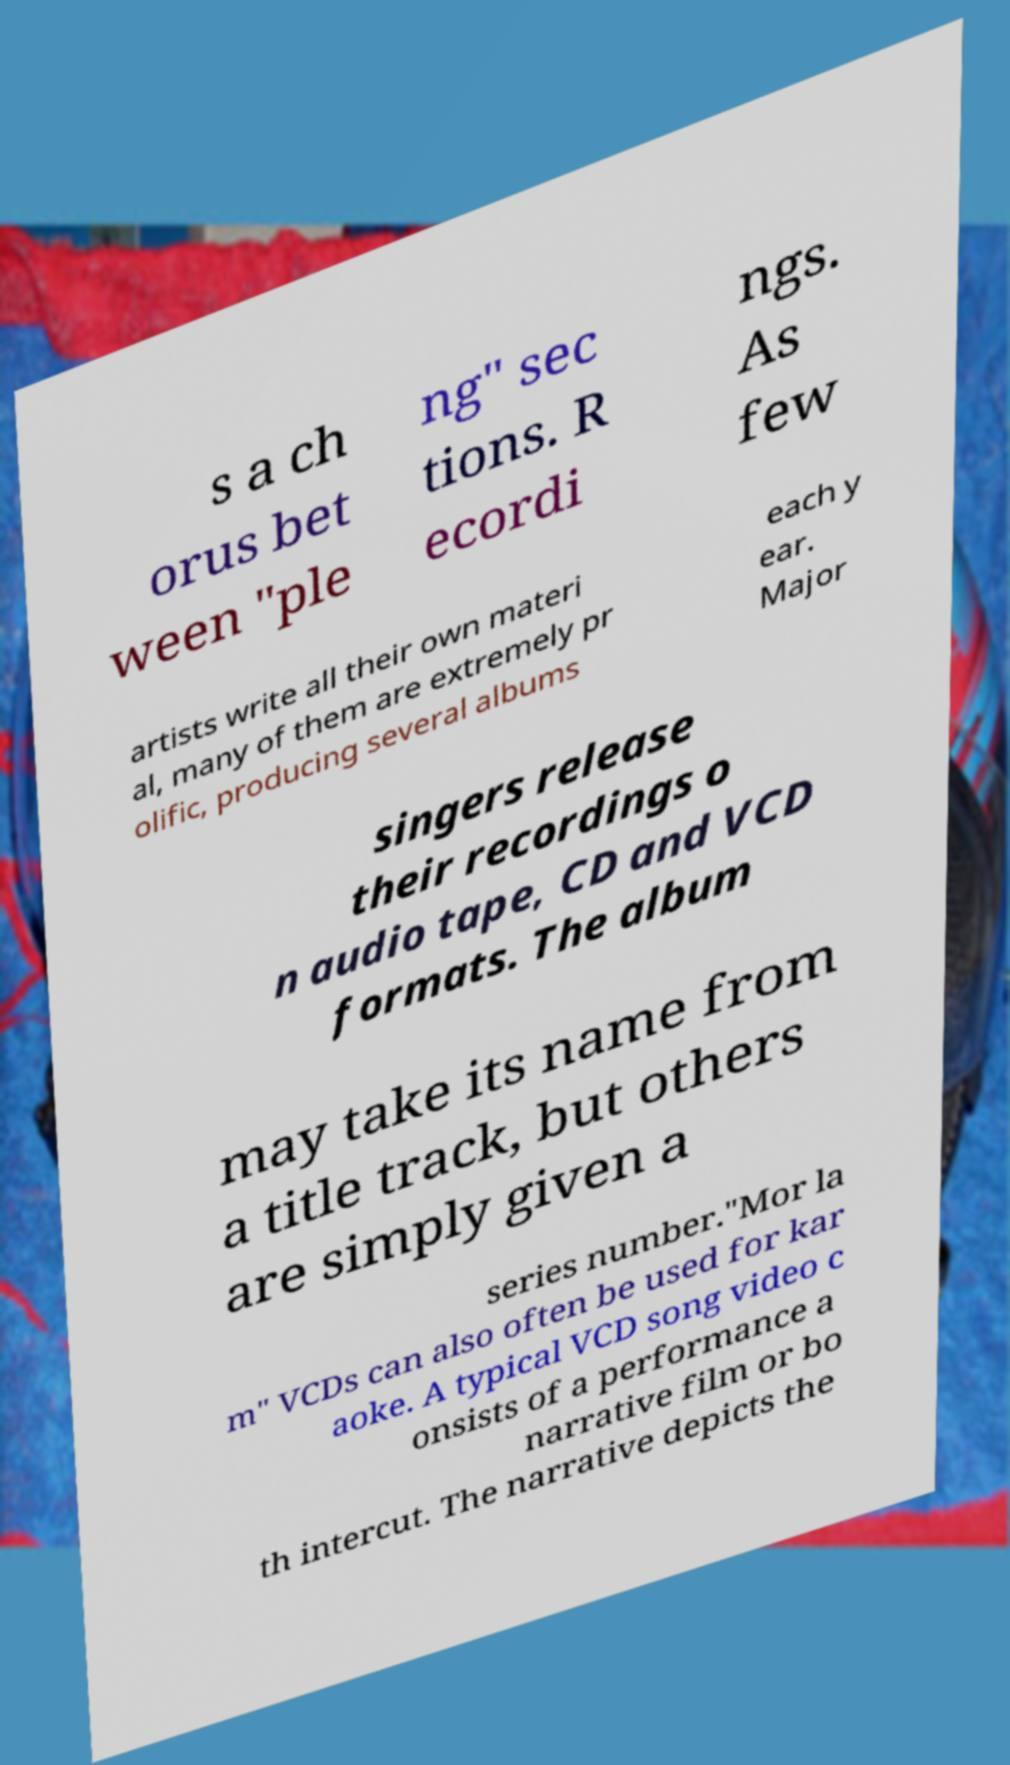Please read and relay the text visible in this image. What does it say? s a ch orus bet ween "ple ng" sec tions. R ecordi ngs. As few artists write all their own materi al, many of them are extremely pr olific, producing several albums each y ear. Major singers release their recordings o n audio tape, CD and VCD formats. The album may take its name from a title track, but others are simply given a series number."Mor la m" VCDs can also often be used for kar aoke. A typical VCD song video c onsists of a performance a narrative film or bo th intercut. The narrative depicts the 